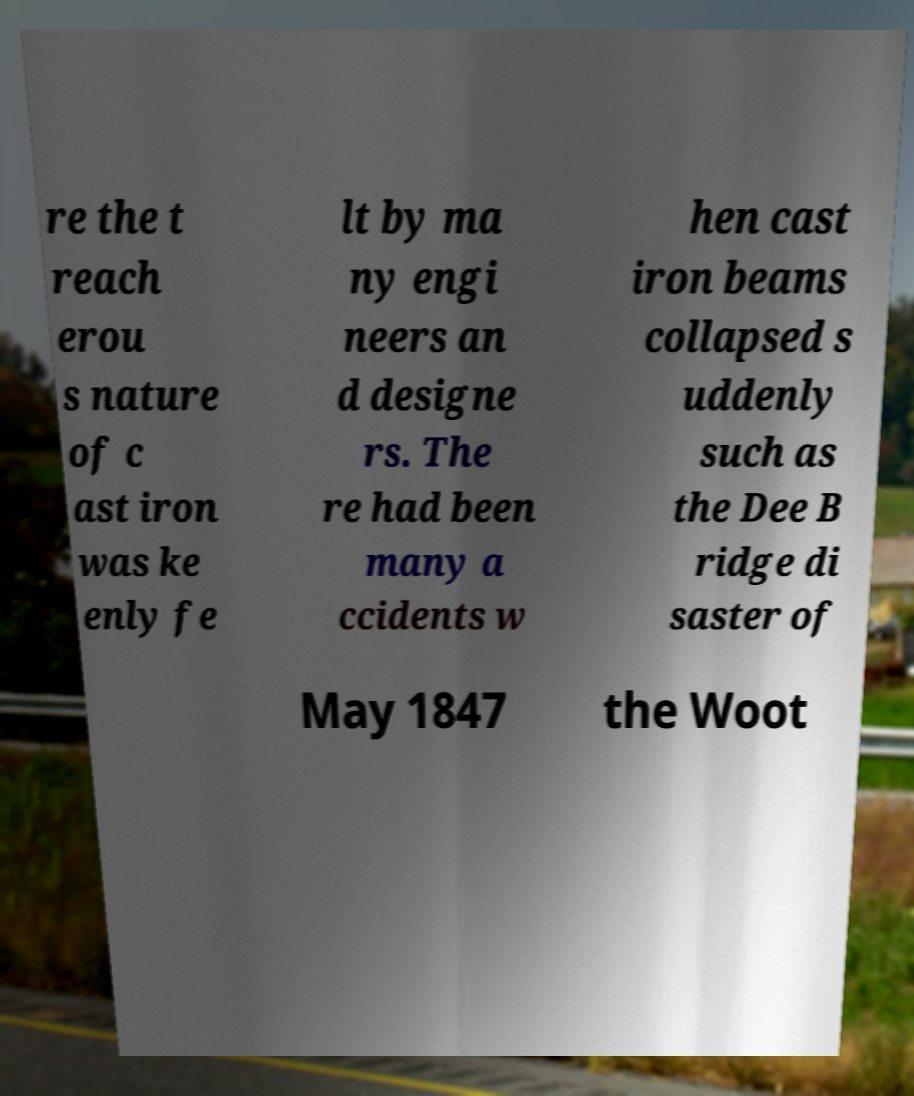For documentation purposes, I need the text within this image transcribed. Could you provide that? re the t reach erou s nature of c ast iron was ke enly fe lt by ma ny engi neers an d designe rs. The re had been many a ccidents w hen cast iron beams collapsed s uddenly such as the Dee B ridge di saster of May 1847 the Woot 